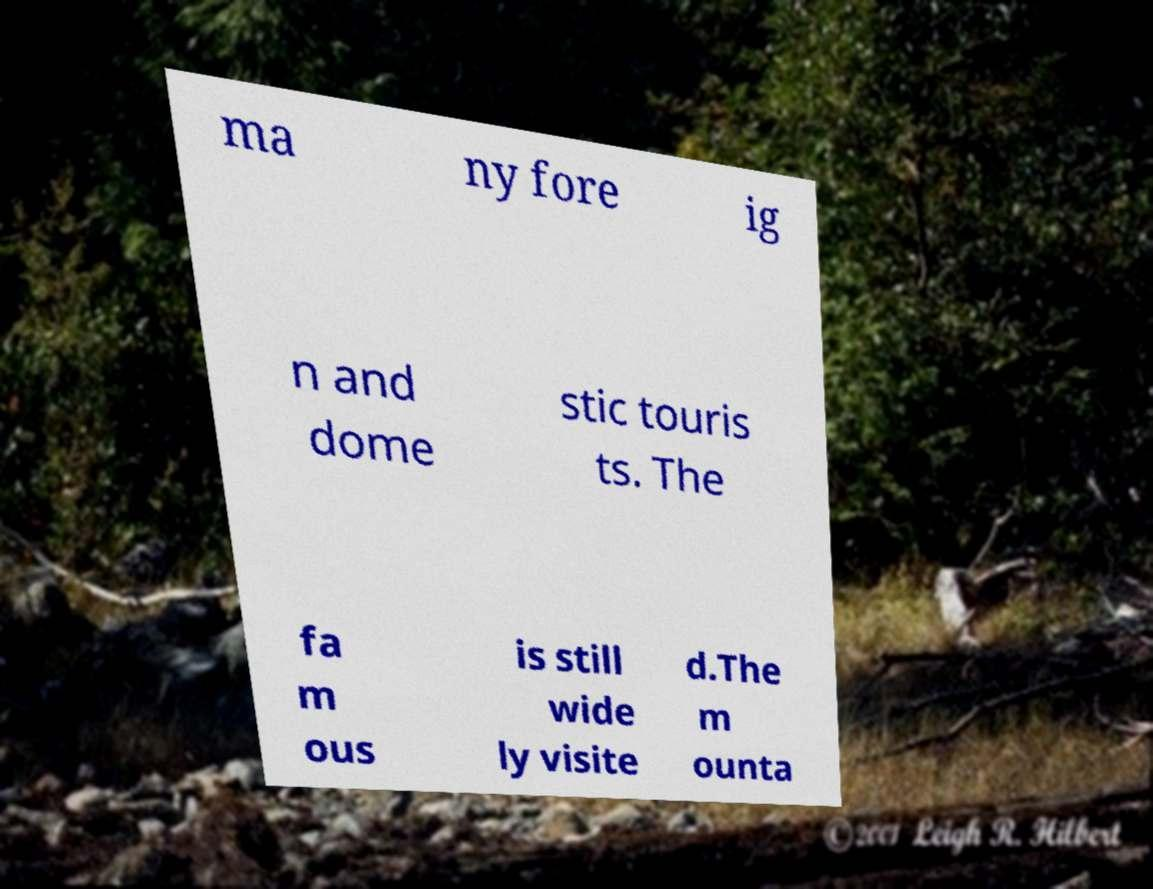What messages or text are displayed in this image? I need them in a readable, typed format. ma ny fore ig n and dome stic touris ts. The fa m ous is still wide ly visite d.The m ounta 